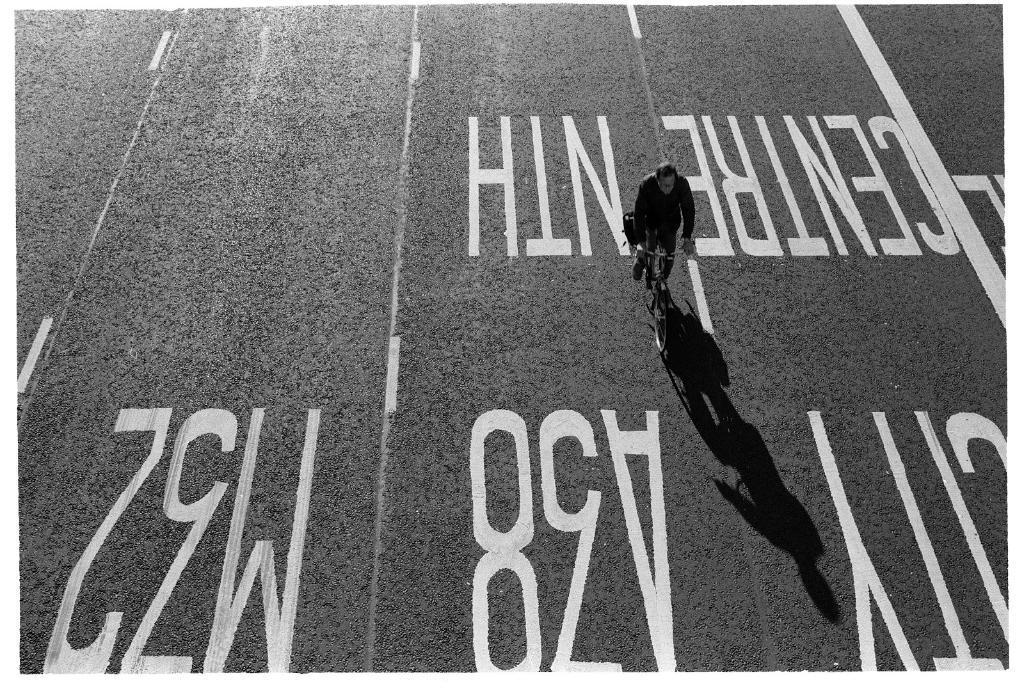<image>
Provide a brief description of the given image. A man on a bicycle rides down central north street. 